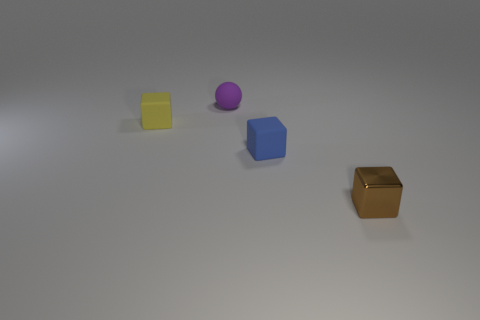There is a small matte block in front of the tiny rubber object that is to the left of the tiny ball; are there any tiny blocks that are left of it?
Your answer should be very brief. Yes. What number of other objects are the same color as the small ball?
Provide a short and direct response. 0. Do the rubber block that is behind the blue matte block and the matte cube on the right side of the small yellow thing have the same size?
Offer a terse response. Yes. Are there an equal number of blue matte cubes that are behind the shiny block and purple balls that are behind the small ball?
Provide a short and direct response. No. Is there any other thing that is the same material as the small brown block?
Provide a succinct answer. No. Is the size of the brown thing the same as the rubber object in front of the tiny yellow cube?
Offer a terse response. Yes. There is a tiny thing that is right of the matte thing right of the small rubber ball; what is its material?
Give a very brief answer. Metal. Are there the same number of tiny metal cubes that are left of the small yellow matte thing and rubber cubes?
Keep it short and to the point. No. What is the color of the tiny thing that is behind the tiny cube that is behind the blue cube?
Offer a terse response. Purple. What number of brown things are either rubber objects or small rubber blocks?
Make the answer very short. 0. 